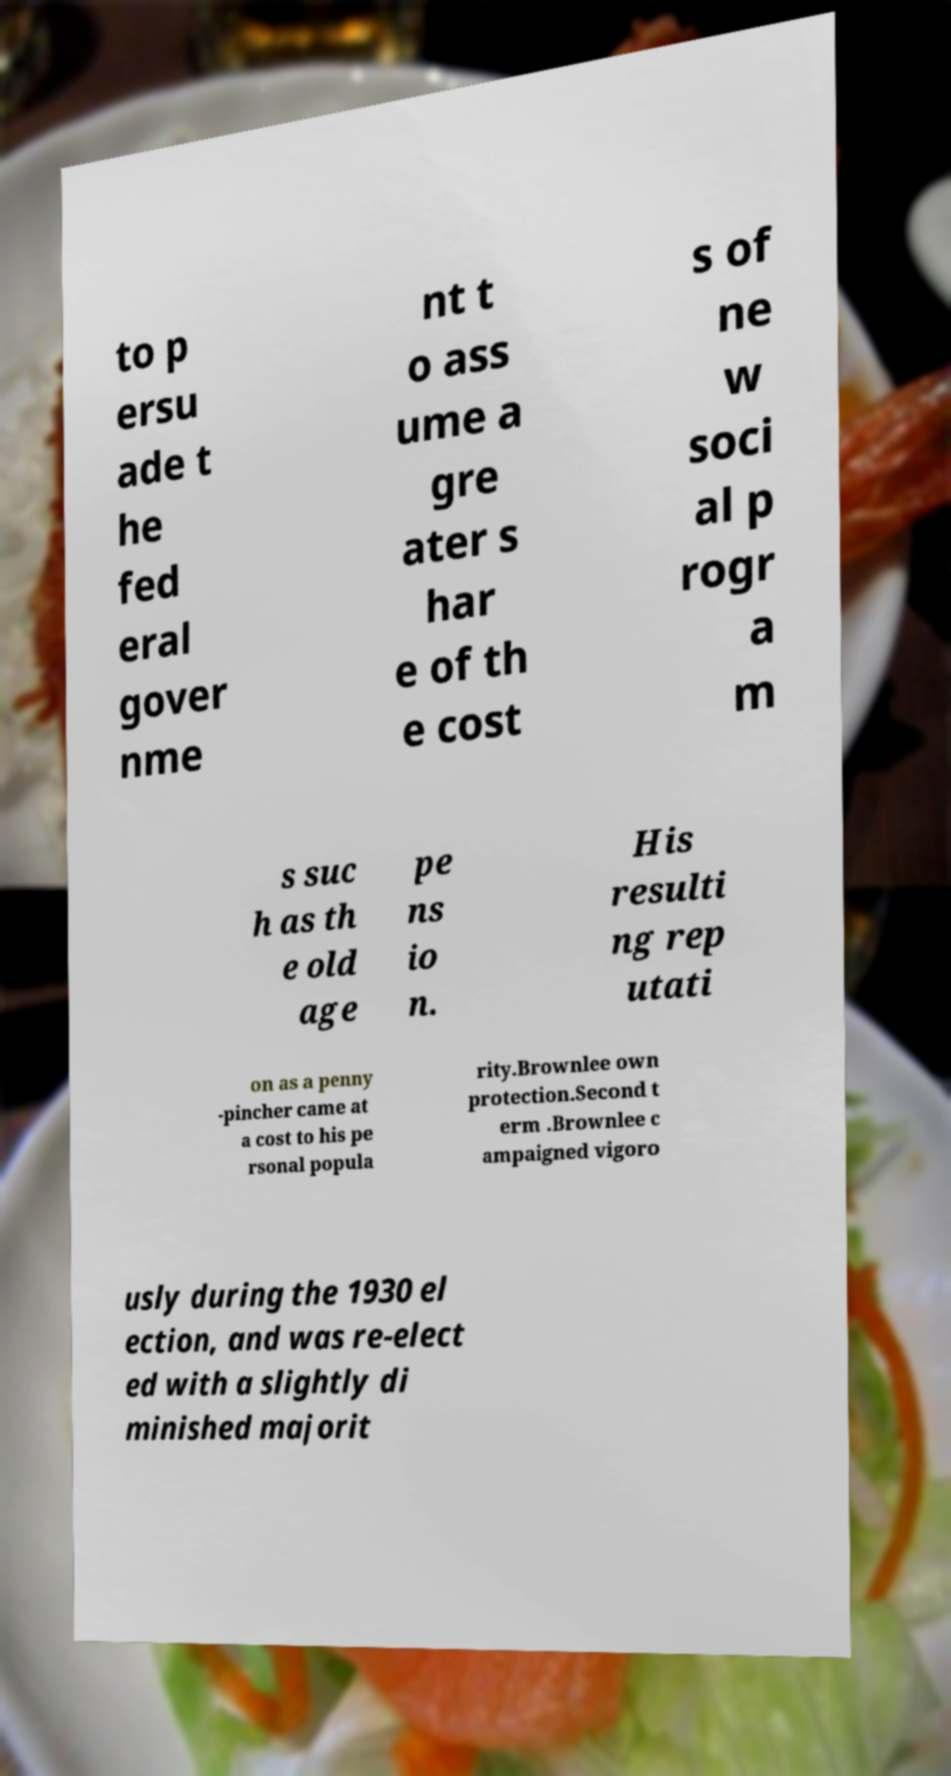Can you read and provide the text displayed in the image?This photo seems to have some interesting text. Can you extract and type it out for me? to p ersu ade t he fed eral gover nme nt t o ass ume a gre ater s har e of th e cost s of ne w soci al p rogr a m s suc h as th e old age pe ns io n. His resulti ng rep utati on as a penny -pincher came at a cost to his pe rsonal popula rity.Brownlee own protection.Second t erm .Brownlee c ampaigned vigoro usly during the 1930 el ection, and was re-elect ed with a slightly di minished majorit 